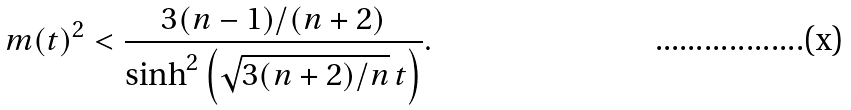Convert formula to latex. <formula><loc_0><loc_0><loc_500><loc_500>m ( t ) ^ { 2 } < \frac { 3 ( n - 1 ) / ( n + 2 ) } { \sinh ^ { 2 } \left ( \sqrt { 3 ( n + 2 ) / n } \, t \right ) } .</formula> 